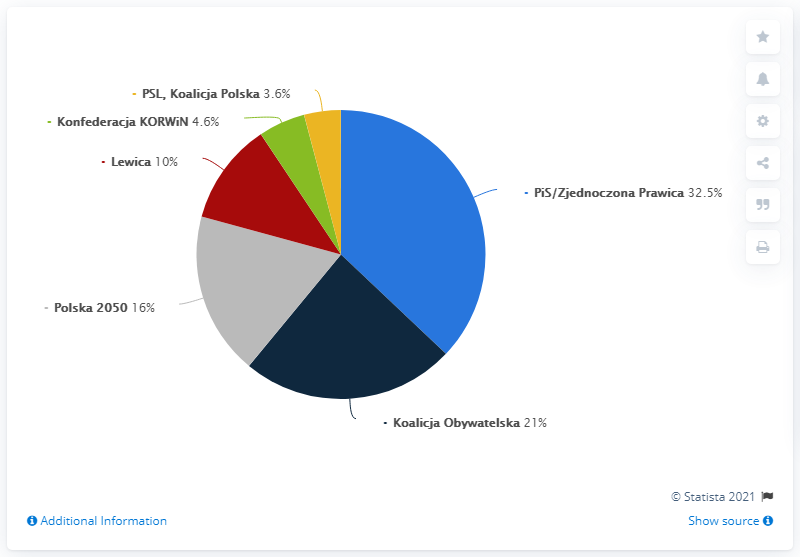Outline some significant characteristics in this image. The support percentage of the top three parties combined is 69.5%. The party that receives the most support is the PiS or United Right. 